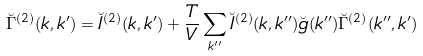<formula> <loc_0><loc_0><loc_500><loc_500>\breve { \Gamma } ^ { ( 2 ) } ( k , k ^ { \prime } ) = \breve { I } ^ { ( 2 ) } ( k , k ^ { \prime } ) + \frac { T } { V } \sum _ { k ^ { \prime \prime } } \breve { I } ^ { ( 2 ) } ( k , k ^ { \prime \prime } ) \breve { g } ( k ^ { \prime \prime } ) \breve { \Gamma } ^ { ( 2 ) } ( k ^ { \prime \prime } , k ^ { \prime } )</formula> 